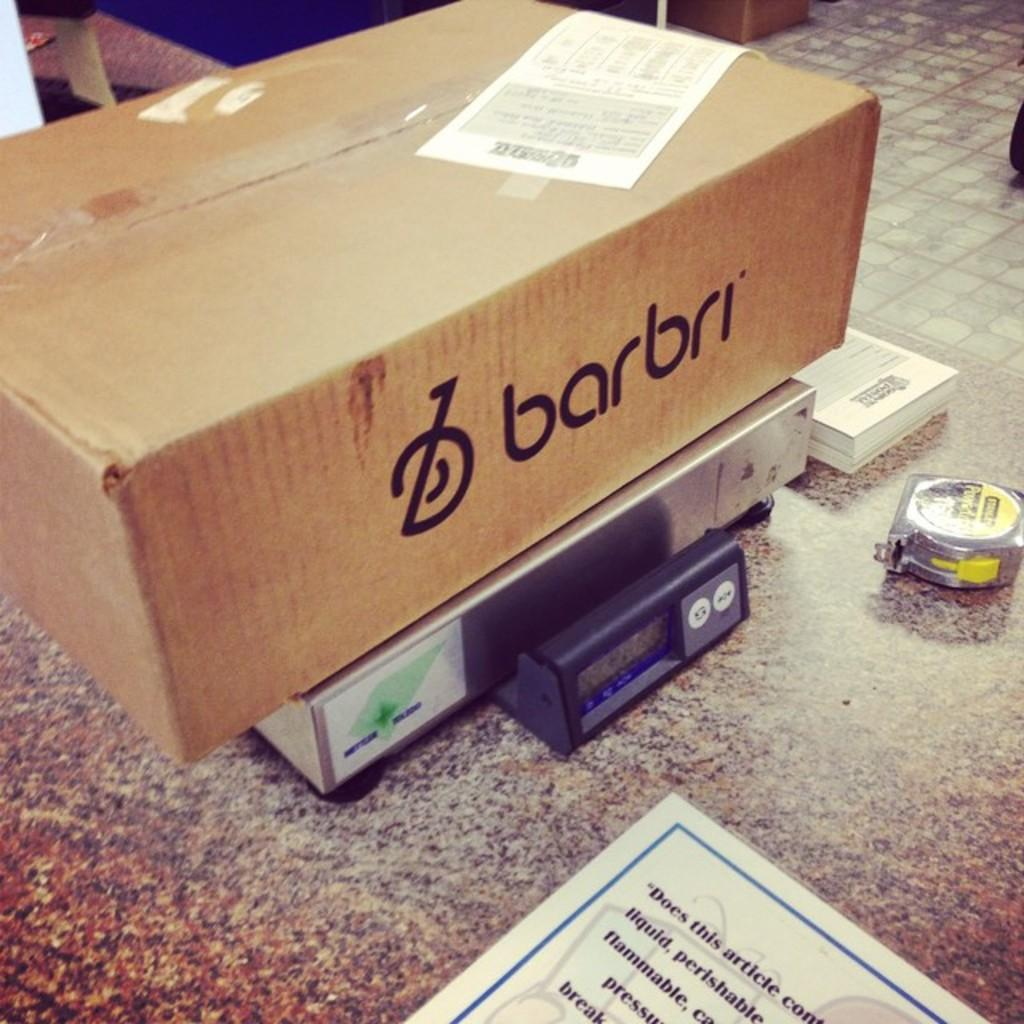<image>
Give a short and clear explanation of the subsequent image. A cardboard box placed on a scale, the box is from Barbri. 